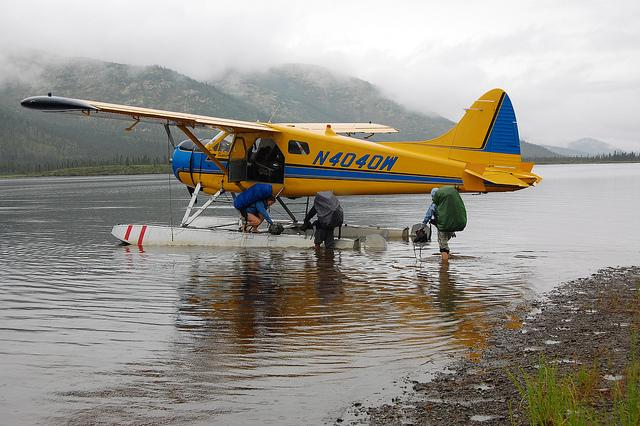What type of plane is being boarded? seaplane 